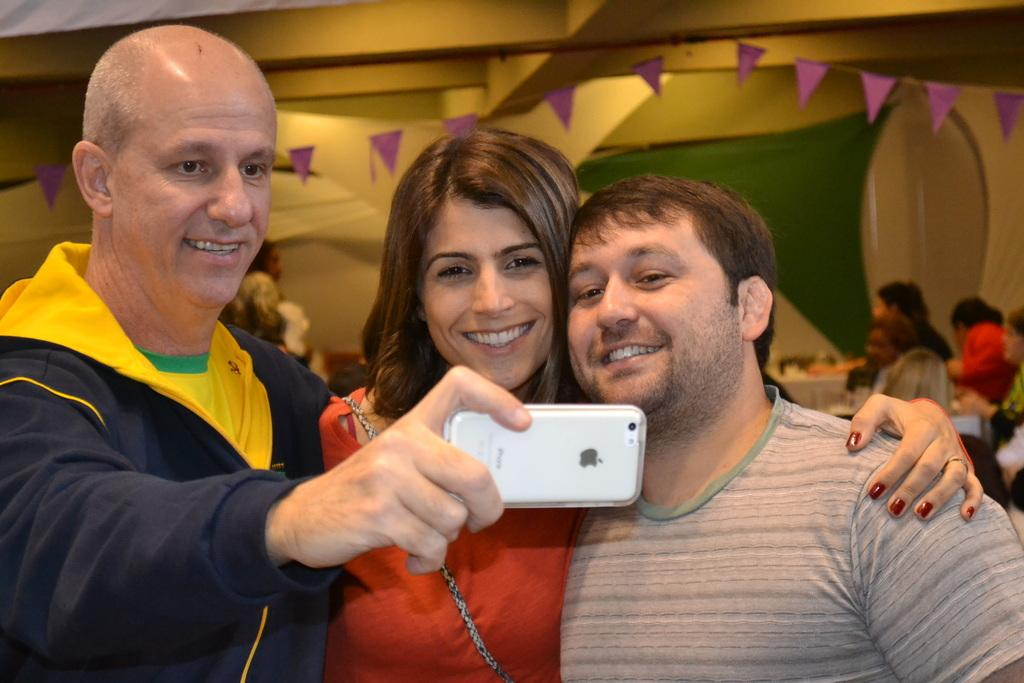How many people are present in the image? There are three people in the image. What is the man holding in his hand? The man is holding a phone in his hand. What is the man doing with the phone? The man is taking a picture. What type of credit card is the man using to take the picture? There is no credit card present in the image, and the man is using a phone to take the picture. 